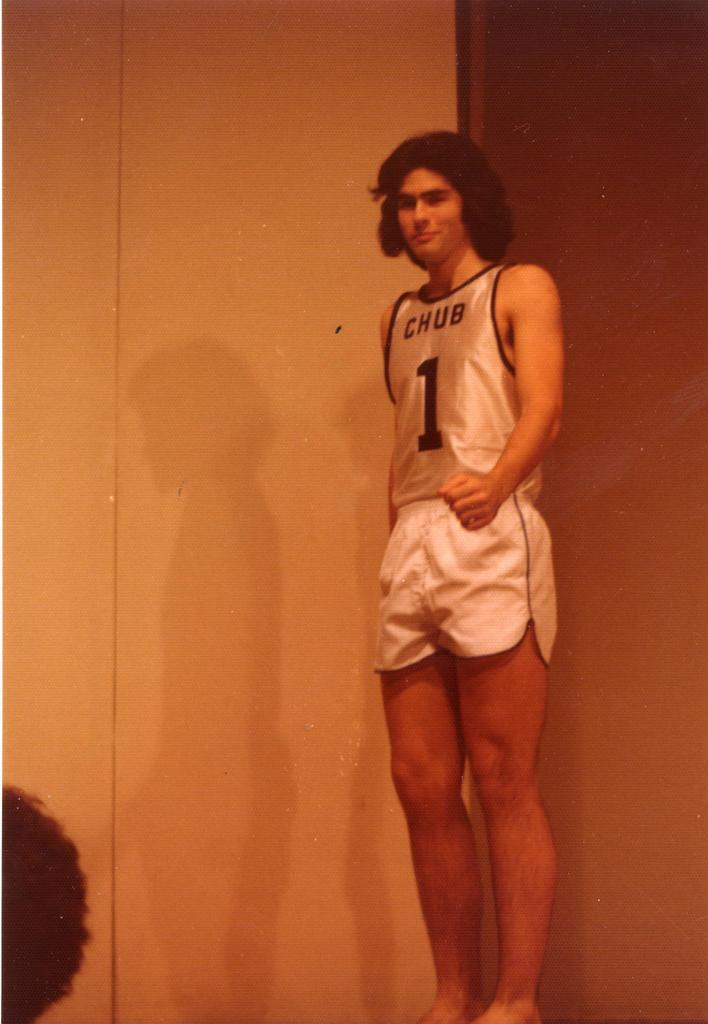<image>
Relay a brief, clear account of the picture shown. Chub shows off their uniform on a stage. 